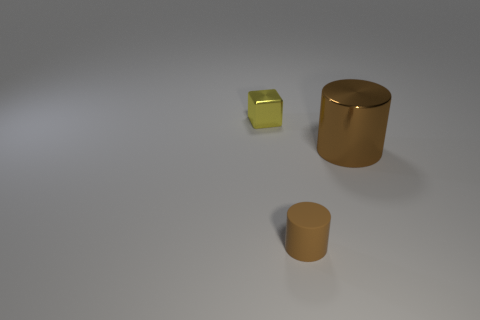Add 1 brown cylinders. How many objects exist? 4 Subtract all cylinders. How many objects are left? 1 Subtract all small brown cylinders. Subtract all rubber things. How many objects are left? 1 Add 2 matte cylinders. How many matte cylinders are left? 3 Add 1 tiny yellow things. How many tiny yellow things exist? 2 Subtract 0 yellow cylinders. How many objects are left? 3 